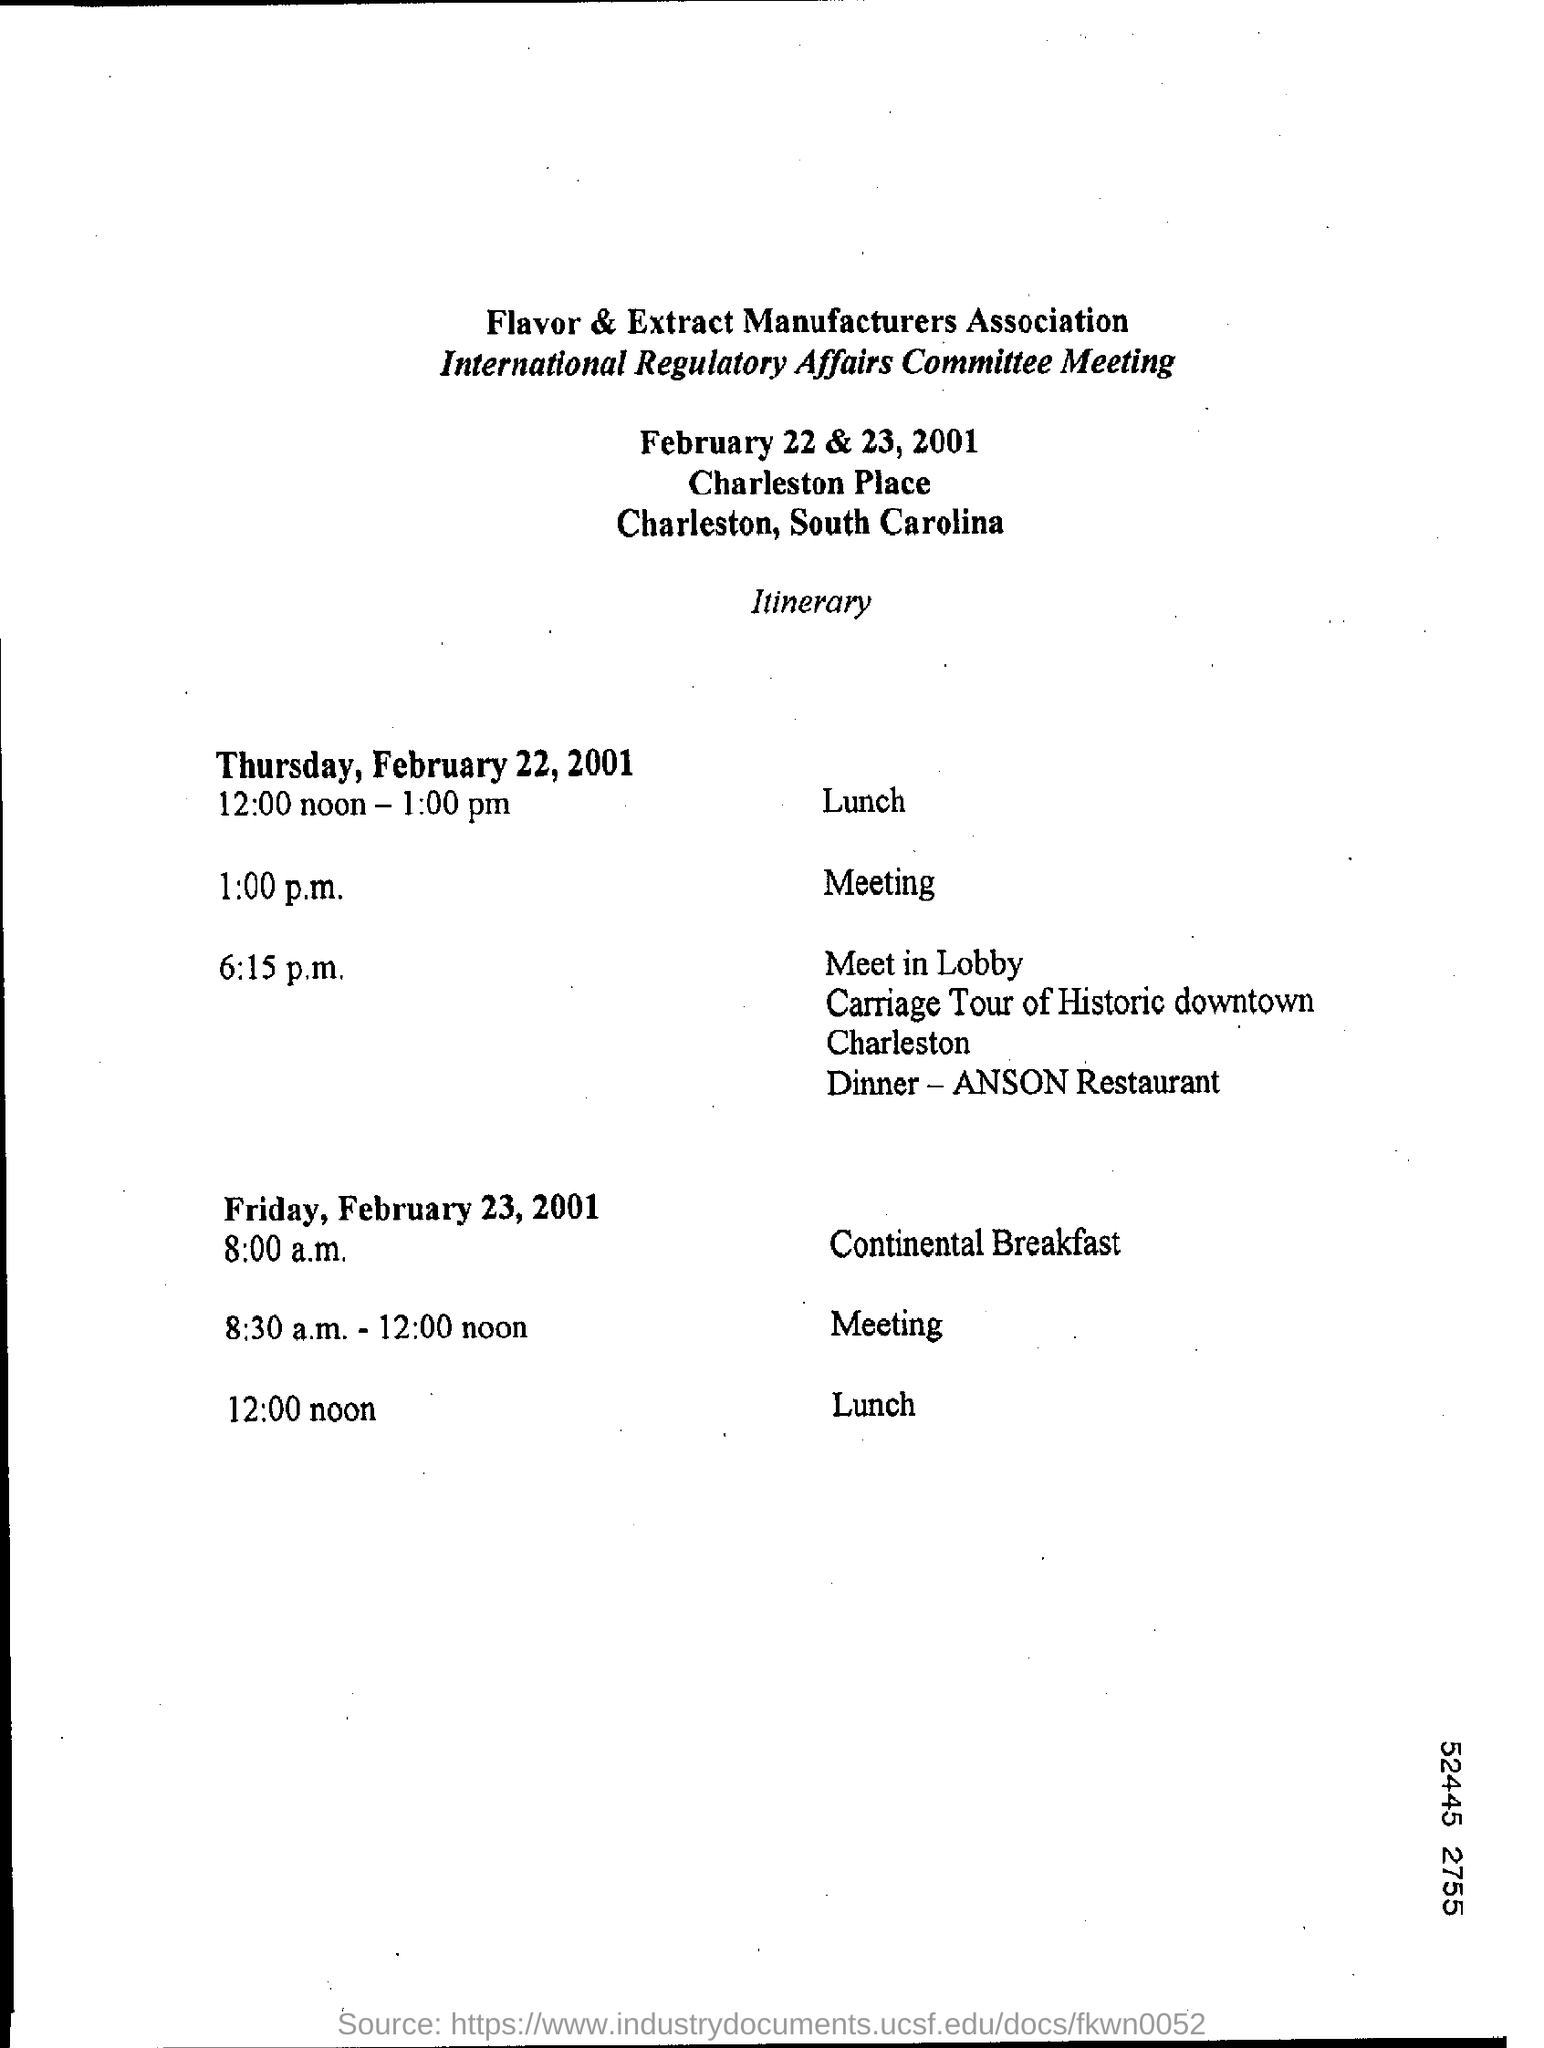Mention a couple of crucial points in this snapshot. The time for the meeting on Thursday, February 22, 2001 is 1:00 p.m. The lunch time for Friday, February 23, 2001 is at 12:00 noon. Continental Breakfast for Friday, February 23, 2001, will begin at 8:00 a.m. The meeting for Friday, February 23, 2001 is scheduled to take place between 8:30 a.m. and 12:00 noon. On Thursday, February 22, 2001, lunch will be served from 12:00 noon to 1:00 pm. 